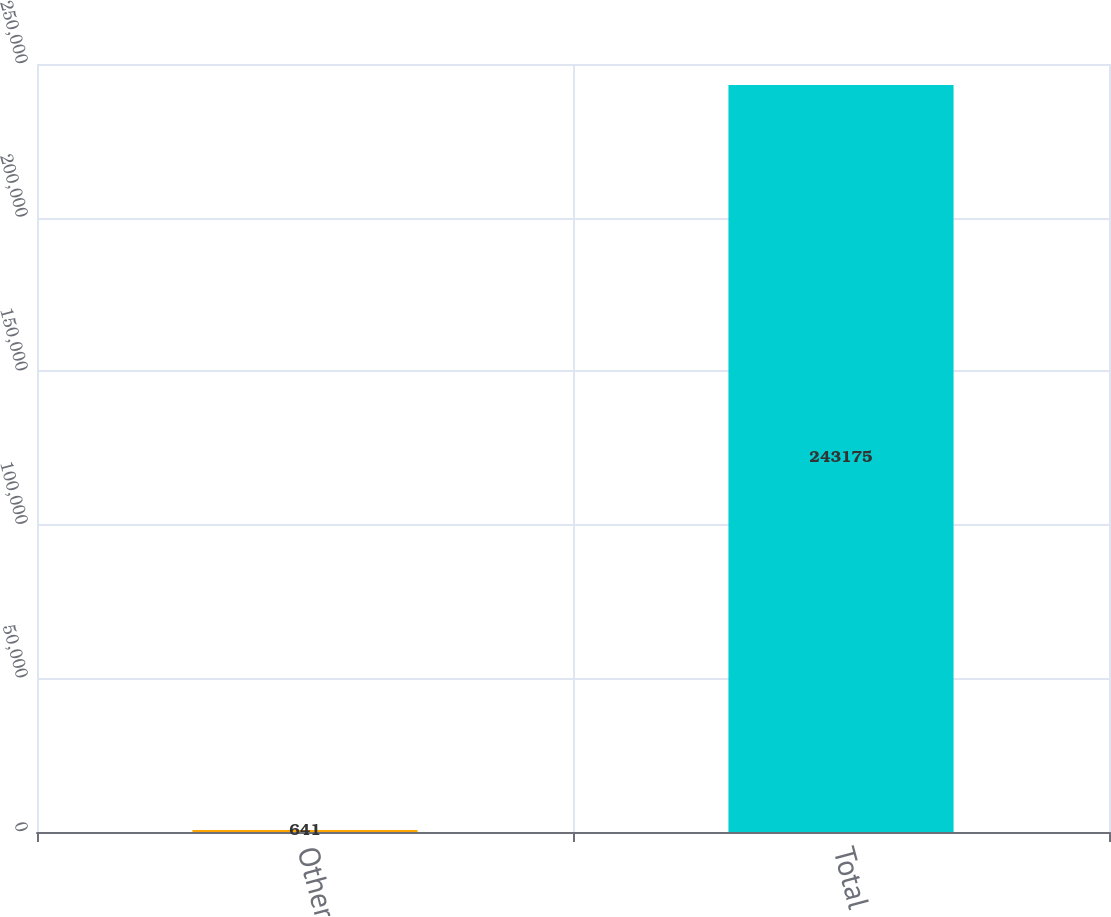Convert chart to OTSL. <chart><loc_0><loc_0><loc_500><loc_500><bar_chart><fcel>Other<fcel>Total<nl><fcel>641<fcel>243175<nl></chart> 